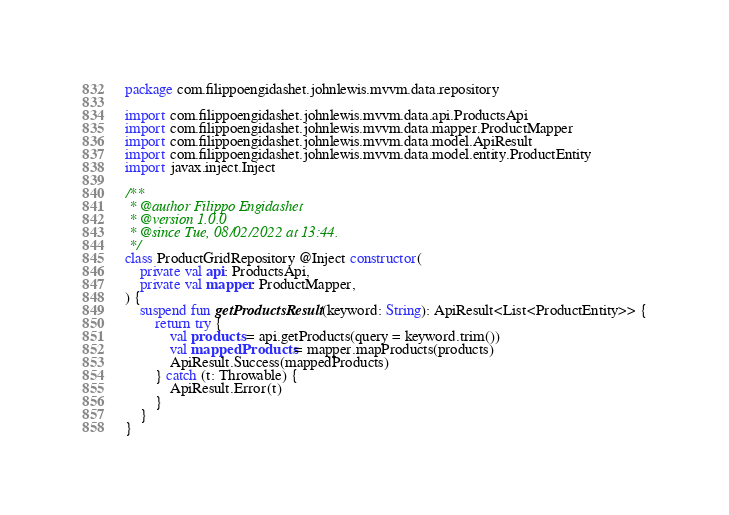<code> <loc_0><loc_0><loc_500><loc_500><_Kotlin_>package com.filippoengidashet.johnlewis.mvvm.data.repository

import com.filippoengidashet.johnlewis.mvvm.data.api.ProductsApi
import com.filippoengidashet.johnlewis.mvvm.data.mapper.ProductMapper
import com.filippoengidashet.johnlewis.mvvm.data.model.ApiResult
import com.filippoengidashet.johnlewis.mvvm.data.model.entity.ProductEntity
import javax.inject.Inject

/**
 * @author Filippo Engidashet
 * @version 1.0.0
 * @since Tue, 08/02/2022 at 13:44.
 */
class ProductGridRepository @Inject constructor(
    private val api: ProductsApi,
    private val mapper: ProductMapper,
) {
    suspend fun getProductsResult(keyword: String): ApiResult<List<ProductEntity>> {
        return try {
            val products = api.getProducts(query = keyword.trim())
            val mappedProducts = mapper.mapProducts(products)
            ApiResult.Success(mappedProducts)
        } catch (t: Throwable) {
            ApiResult.Error(t)
        }
    }
}
</code> 